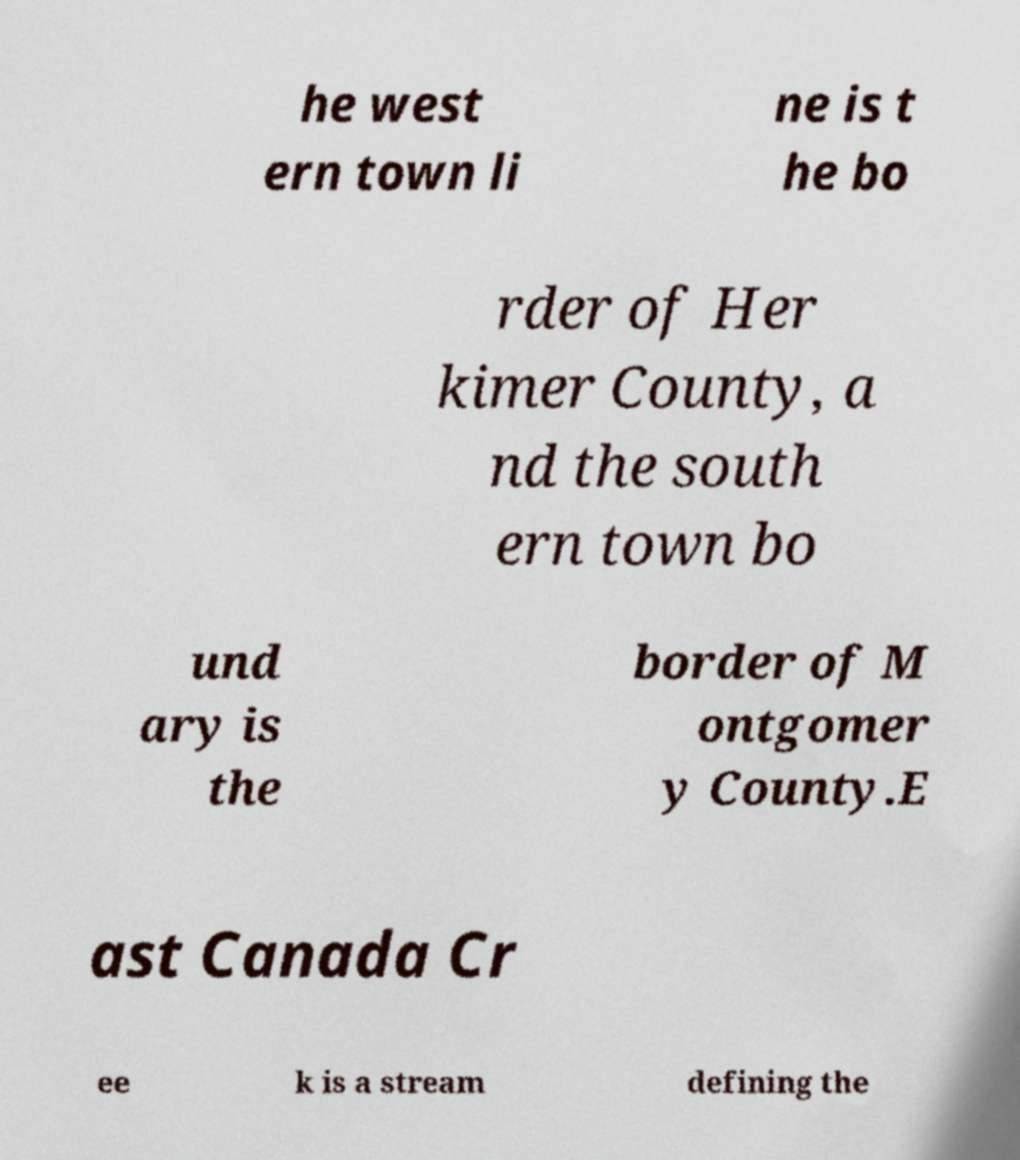Please read and relay the text visible in this image. What does it say? he west ern town li ne is t he bo rder of Her kimer County, a nd the south ern town bo und ary is the border of M ontgomer y County.E ast Canada Cr ee k is a stream defining the 